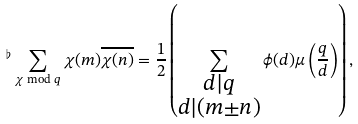Convert formula to latex. <formula><loc_0><loc_0><loc_500><loc_500>{ ^ { \flat } } \sum _ { \chi \bmod q } \chi ( m ) \overline { \chi ( n ) } = \frac { 1 } { 2 } \left ( \sum _ { \substack { d | q \\ d | ( m \pm n ) } } \phi ( d ) \mu \left ( \frac { q } { d } \right ) \right ) ,</formula> 